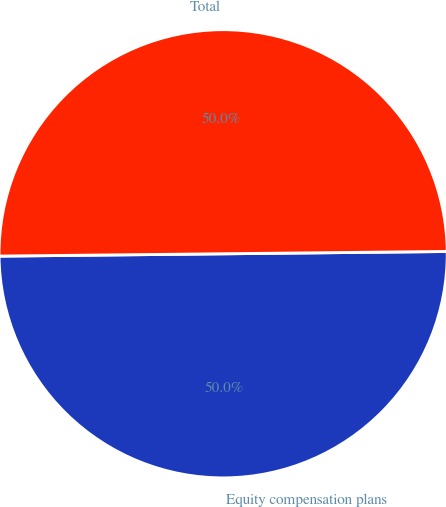Convert chart to OTSL. <chart><loc_0><loc_0><loc_500><loc_500><pie_chart><fcel>Equity compensation plans<fcel>Total<nl><fcel>50.0%<fcel>50.0%<nl></chart> 